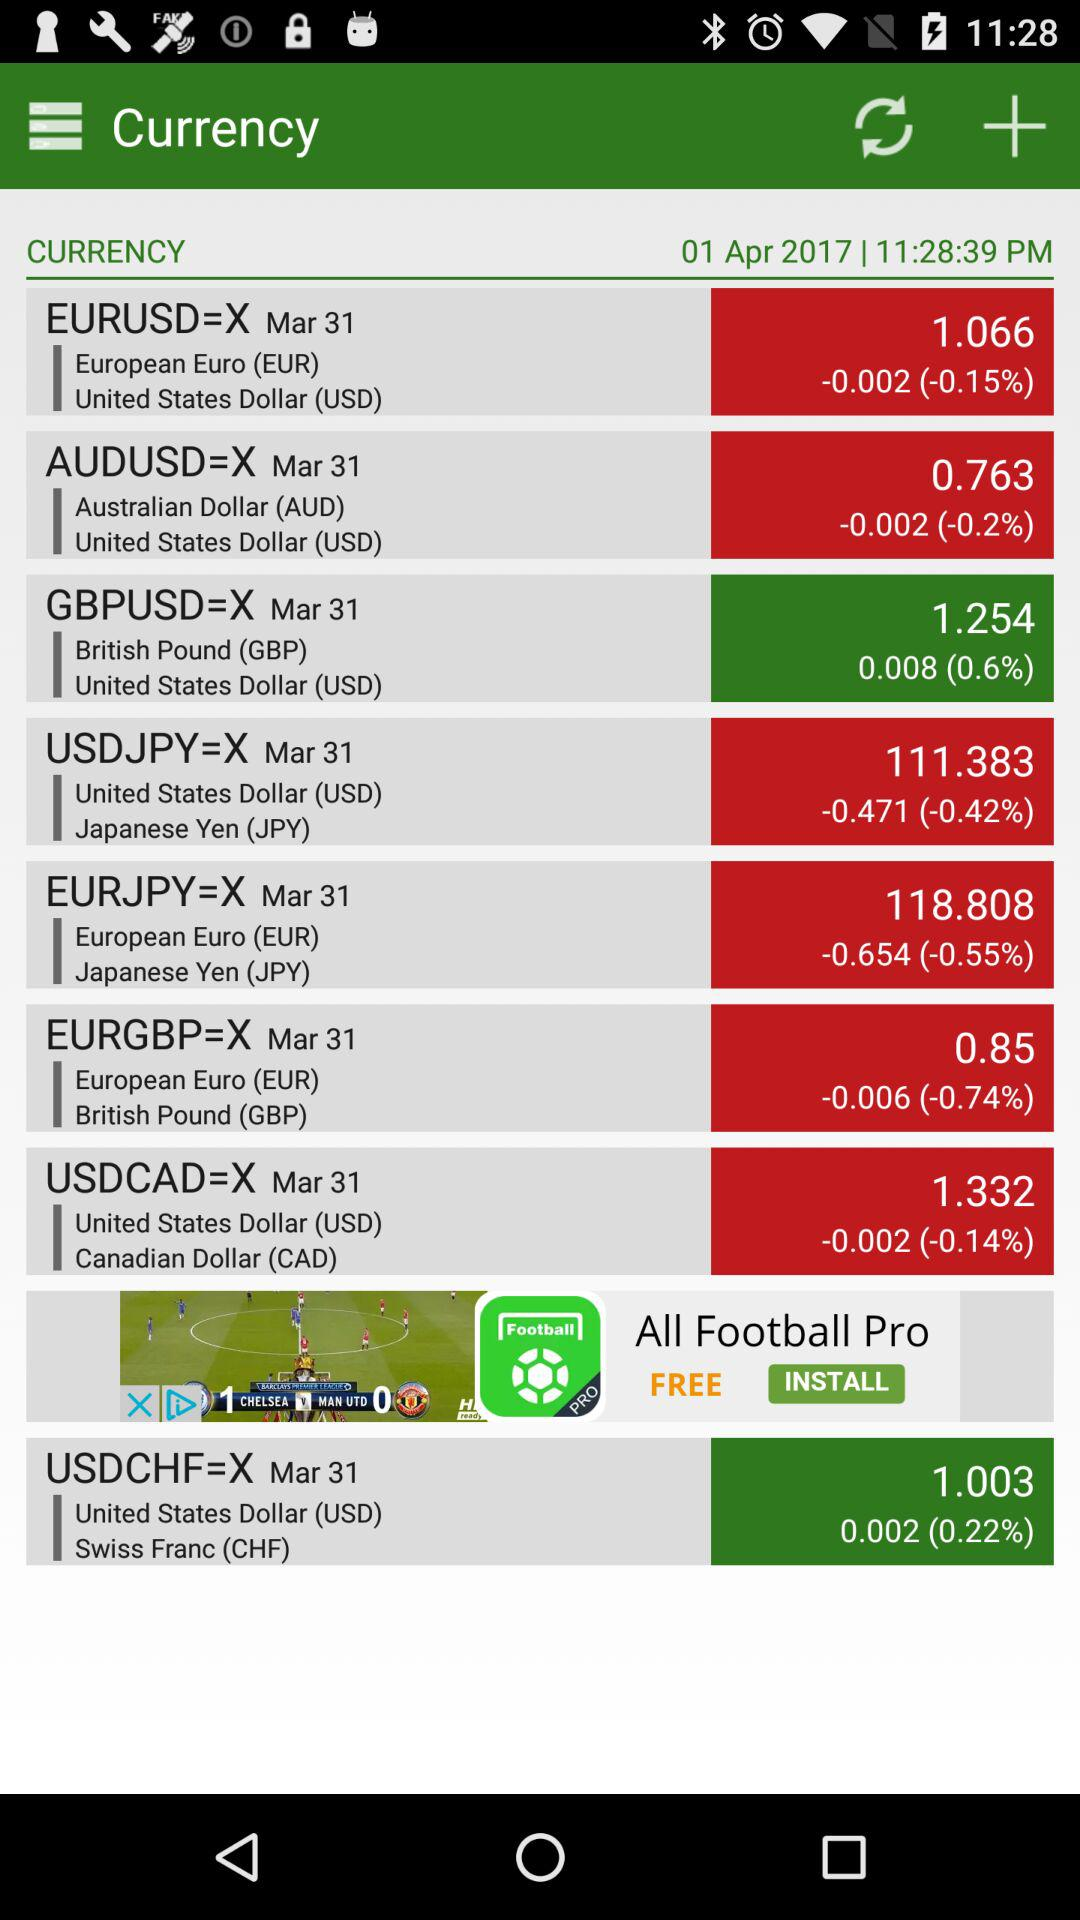How many percent has the EURUSD rate changed since the last update?
Answer the question using a single word or phrase. -0.15% 